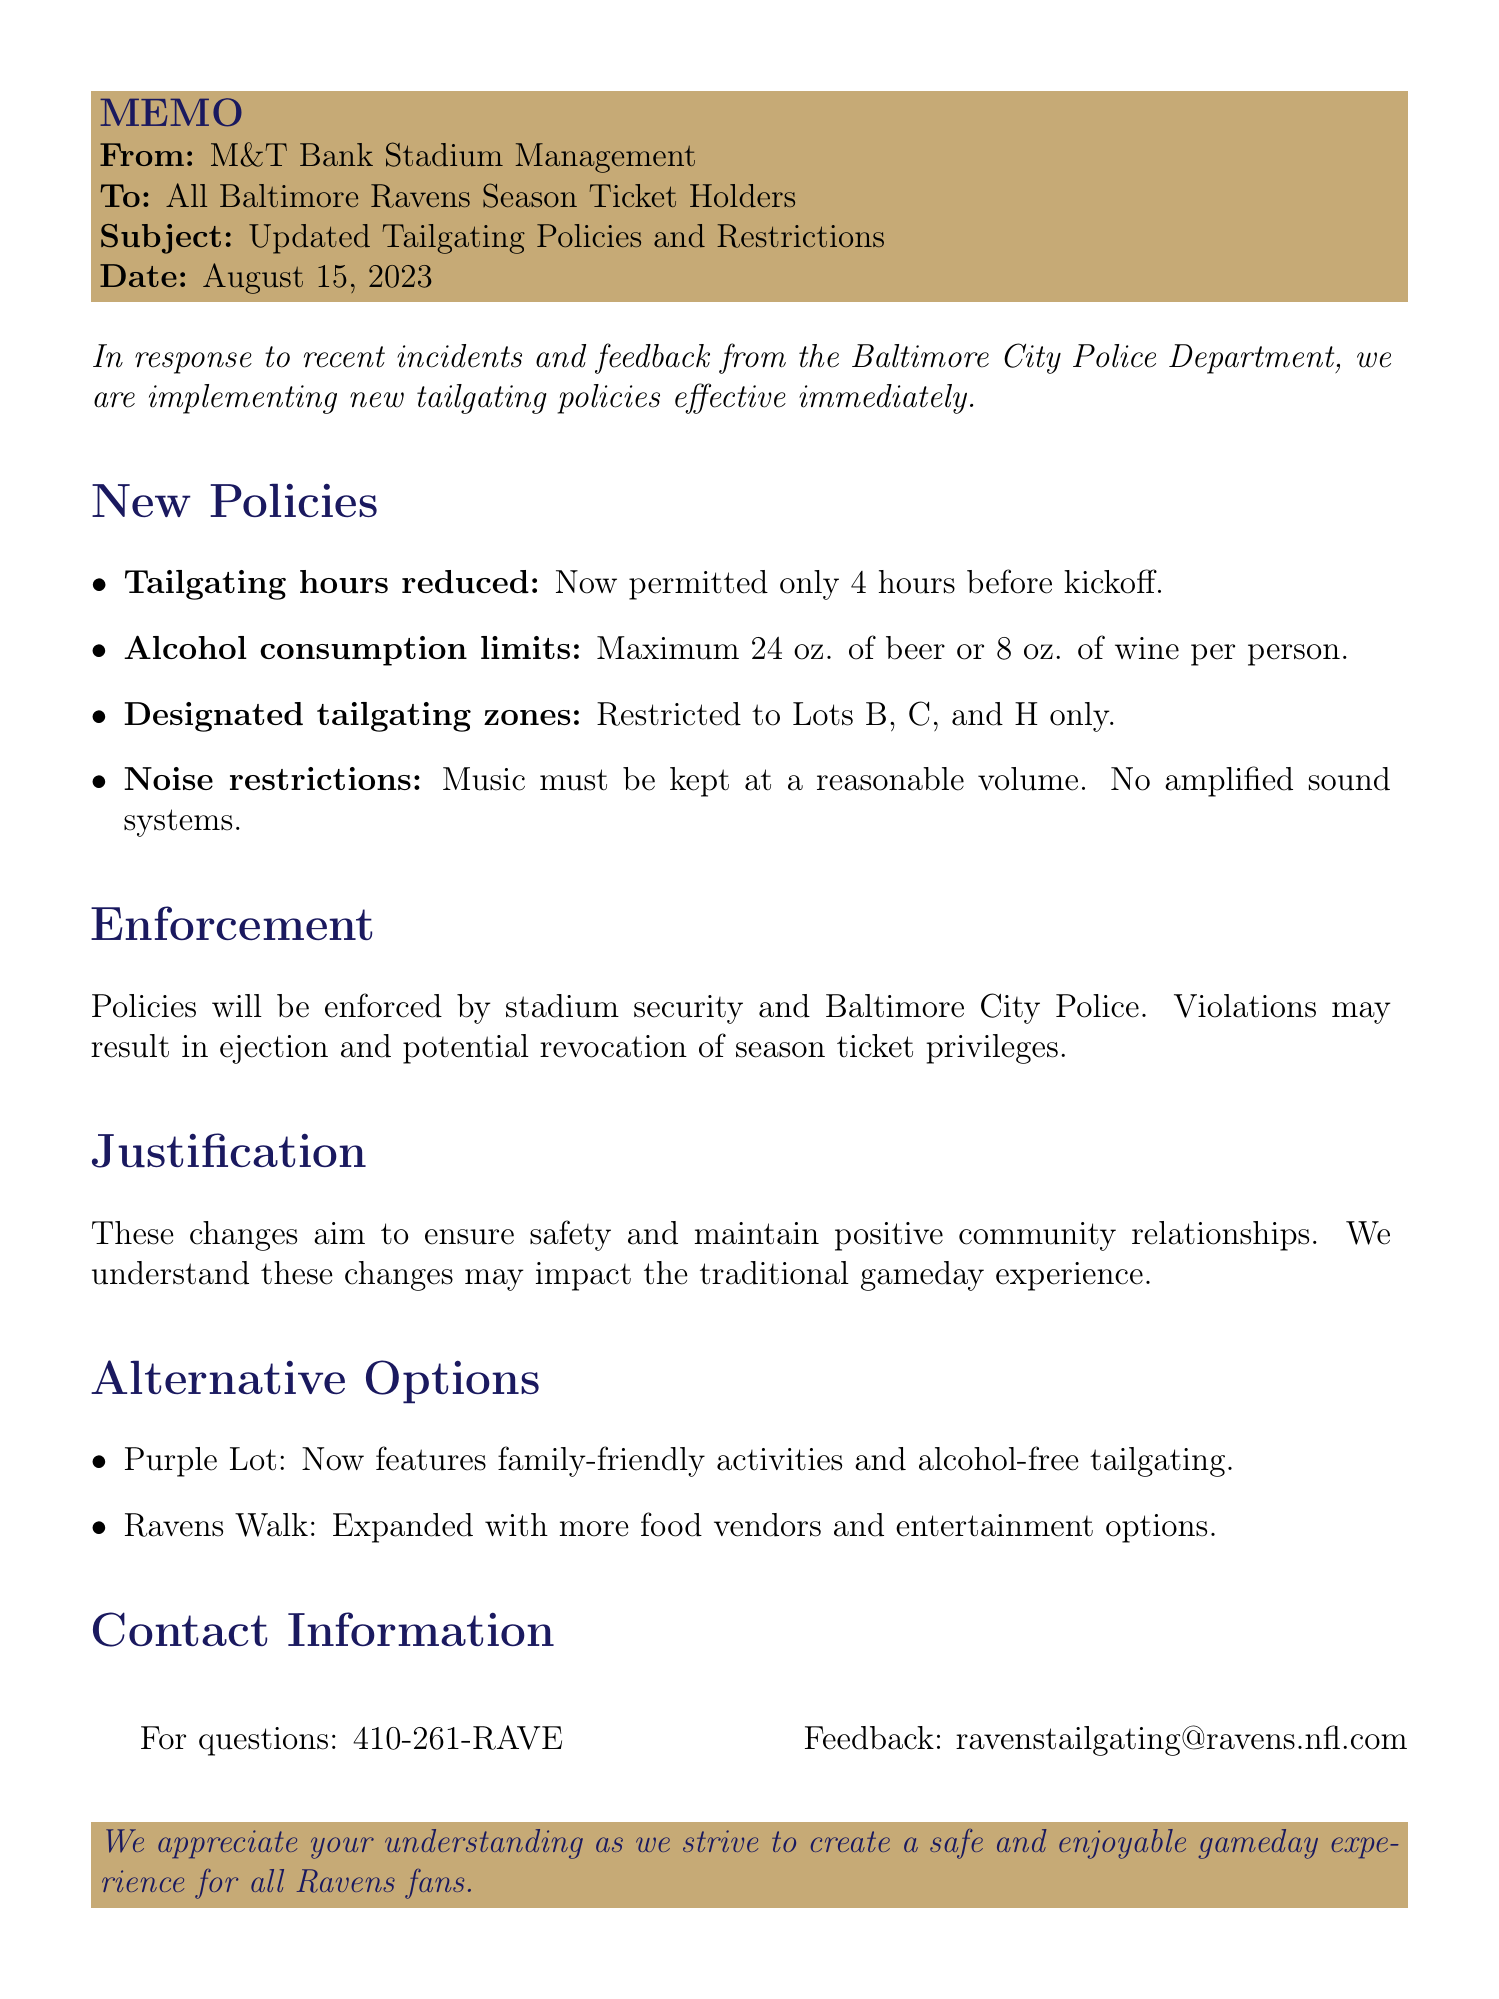What are the new tailgating hours? The tailgating hours have been reduced to 4 hours before kickoff.
Answer: 4 hours What is the alcohol consumption limit per person? The limit is 24 oz. of beer or 8 oz. of wine per person.
Answer: 24 oz. of beer or 8 oz. of wine Which lots are designated for tailgating? Tailgating is restricted to Lots B, C, and H only.
Answer: Lots B, C, and H Who will enforce the new tailgating policies? The policies will be enforced by stadium security and Baltimore City Police.
Answer: Stadium security and Baltimore City Police What is the consequence of violating the new policies? Violations may result in ejection from the premises and potential revocation of season ticket privileges.
Answer: Ejection and potential revocation of season ticket privileges What are the new activities in the Purple Lot? The Purple Lot will now feature family-friendly activities and alcohol-free tailgating.
Answer: Family-friendly activities and alcohol-free tailgating When was the memo issued? The memo was issued on August 15, 2023.
Answer: August 15, 2023 What is the primary justification for these new policies? The primary justification is to ensure the safety and enjoyment of all attendees.
Answer: Safety and enjoyment of all attendees 